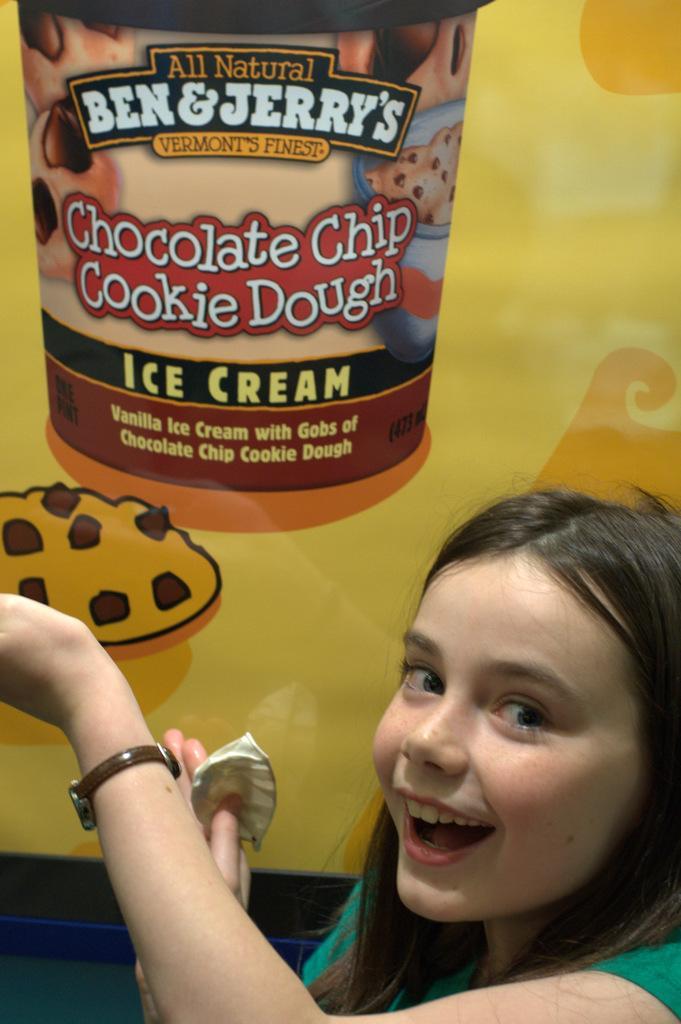Can you describe this image briefly? There is a woman wore watch and we can see a poster of a box. 